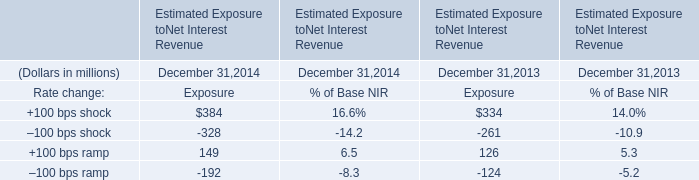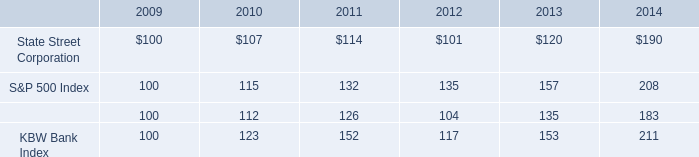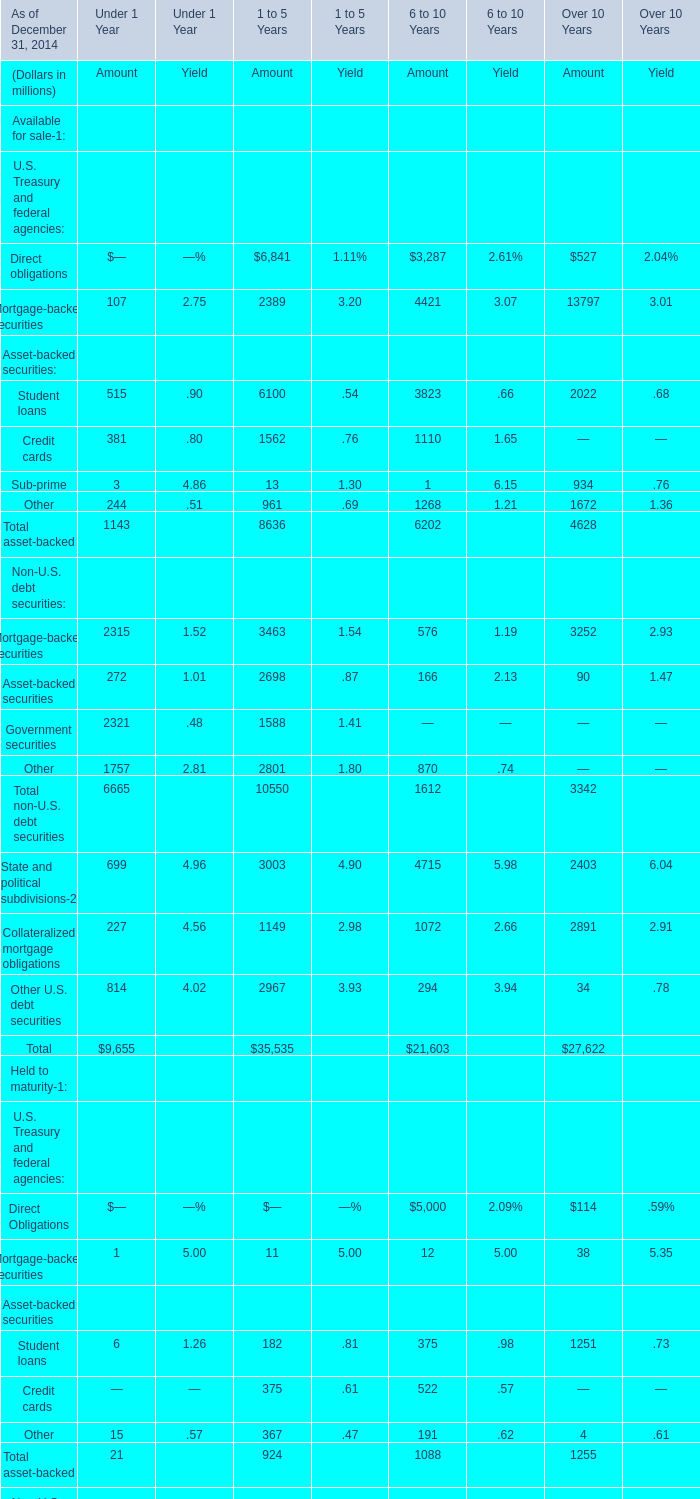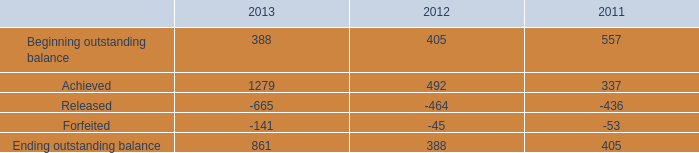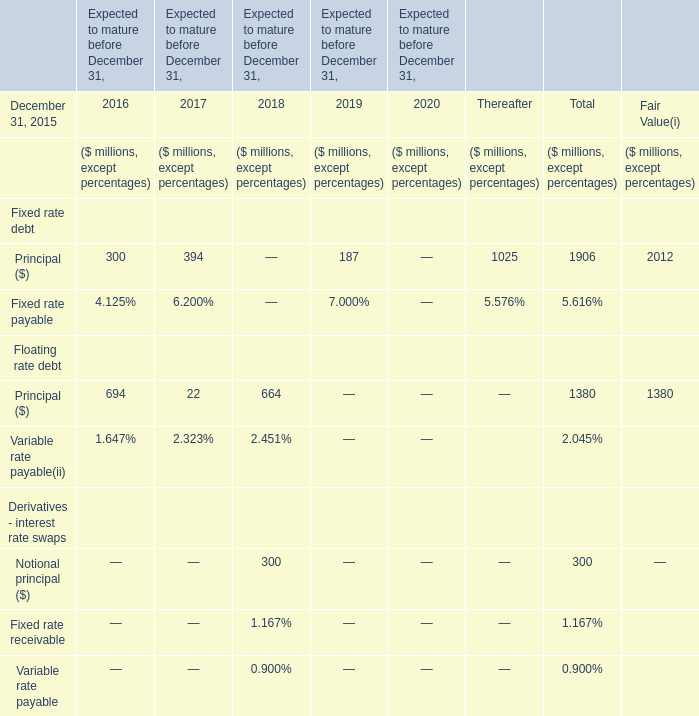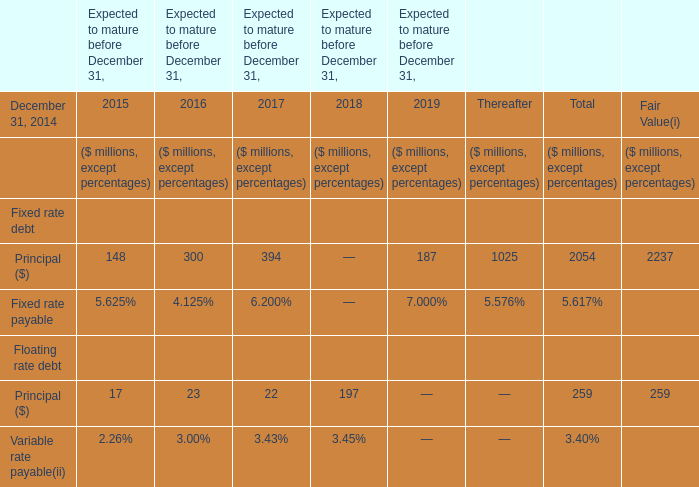In the year with the most Principal what is the growth rate of Principal? 
Computations: ((22 - 23) / 22)
Answer: -0.04545. 